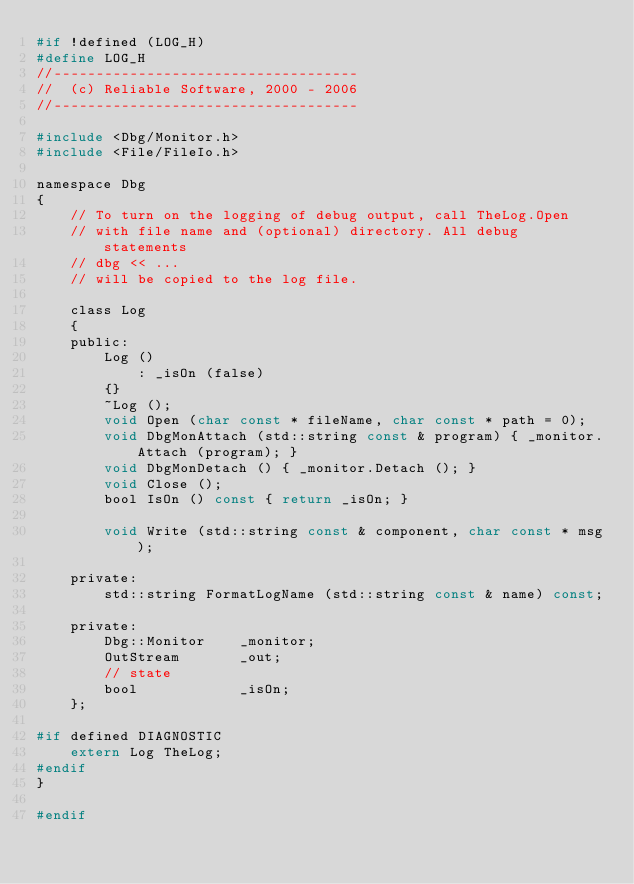<code> <loc_0><loc_0><loc_500><loc_500><_C_>#if !defined (LOG_H)
#define LOG_H
//------------------------------------
//  (c) Reliable Software, 2000 - 2006
//------------------------------------

#include <Dbg/Monitor.h>
#include <File/FileIo.h>

namespace Dbg
{
	// To turn on the logging of debug output, call TheLog.Open 
	// with file name and (optional) directory. All debug statements
	// dbg << ...
	// will be copied to the log file.

	class Log
	{
	public:
		Log ()
			: _isOn (false)
		{}
		~Log ();
		void Open (char const * fileName, char const * path = 0);
		void DbgMonAttach (std::string const & program) { _monitor.Attach (program); }
		void DbgMonDetach () { _monitor.Detach (); }
		void Close ();
		bool IsOn () const { return _isOn; }

		void Write (std::string const & component, char const * msg);

	private:
		std::string FormatLogName (std::string const & name) const;

	private:
		Dbg::Monitor	_monitor;
		OutStream		_out;
		// state
		bool			_isOn;
	};

#if defined DIAGNOSTIC
	extern Log TheLog;
#endif
}

#endif
</code> 